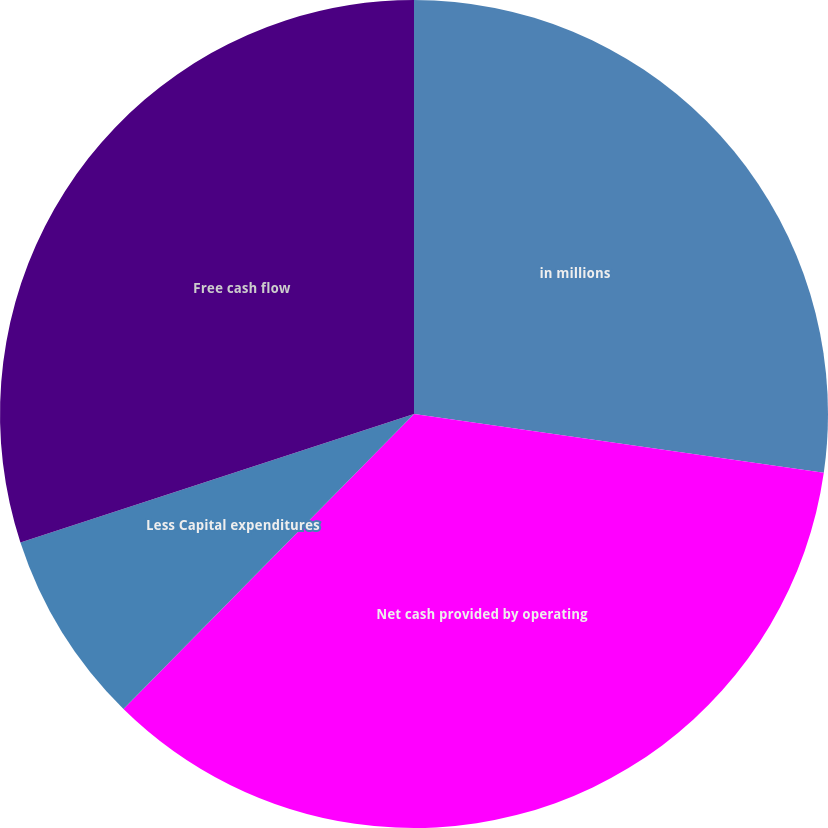<chart> <loc_0><loc_0><loc_500><loc_500><pie_chart><fcel>in millions<fcel>Net cash provided by operating<fcel>Less Capital expenditures<fcel>Free cash flow<nl><fcel>27.27%<fcel>35.11%<fcel>7.6%<fcel>30.02%<nl></chart> 